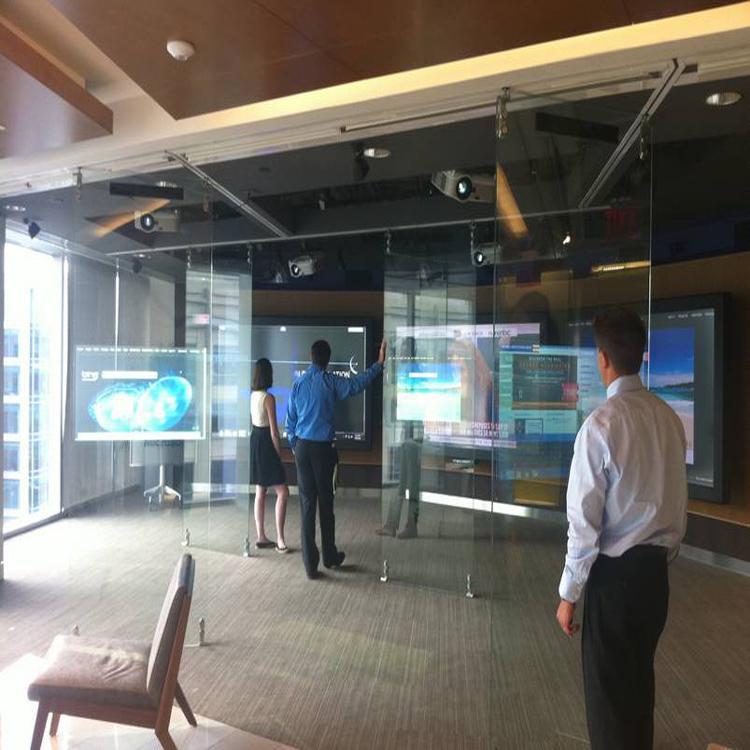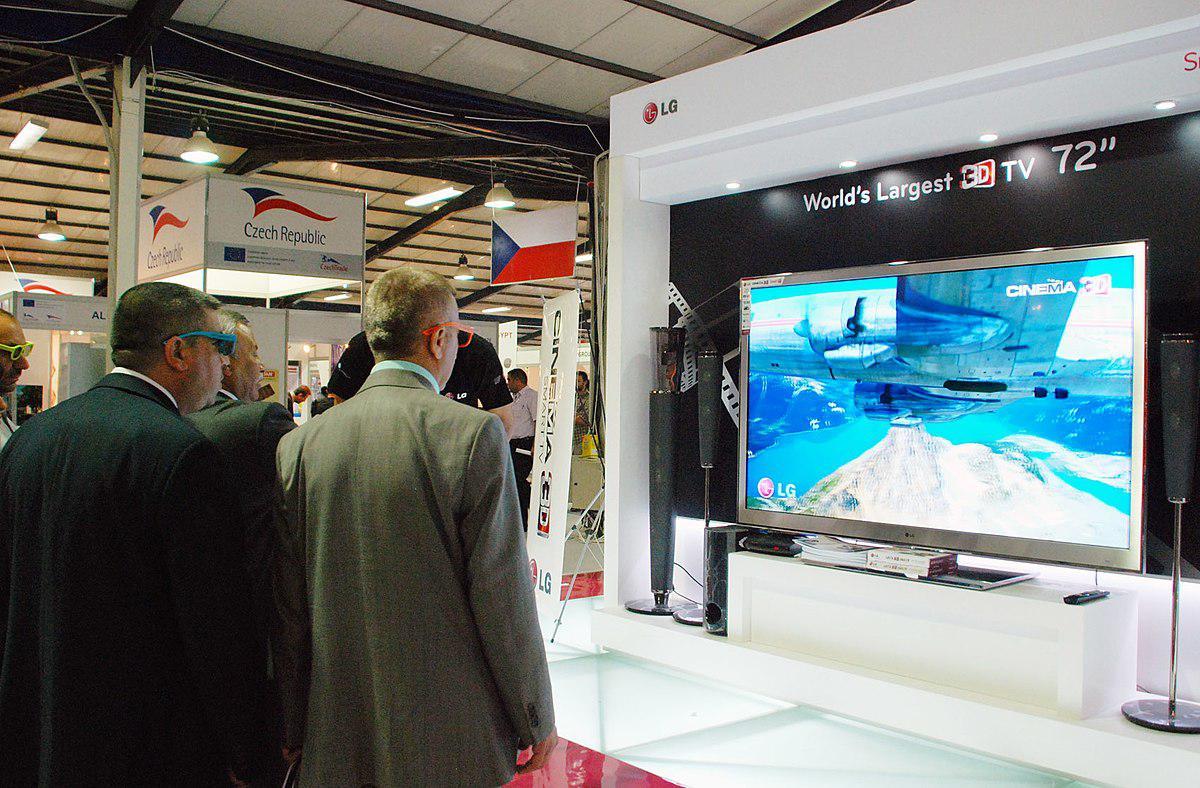The first image is the image on the left, the second image is the image on the right. Considering the images on both sides, is "At least one image includes people facing large screens in front of them." valid? Answer yes or no. Yes. The first image is the image on the left, the second image is the image on the right. Given the left and right images, does the statement "In one image, one woman has one hand at the top of a big-screen TV and is gesturing toward it with the other hand." hold true? Answer yes or no. No. The first image is the image on the left, the second image is the image on the right. Analyze the images presented: Is the assertion "In at least one image there is a woman standing to the right of a TV display showing it." valid? Answer yes or no. No. 